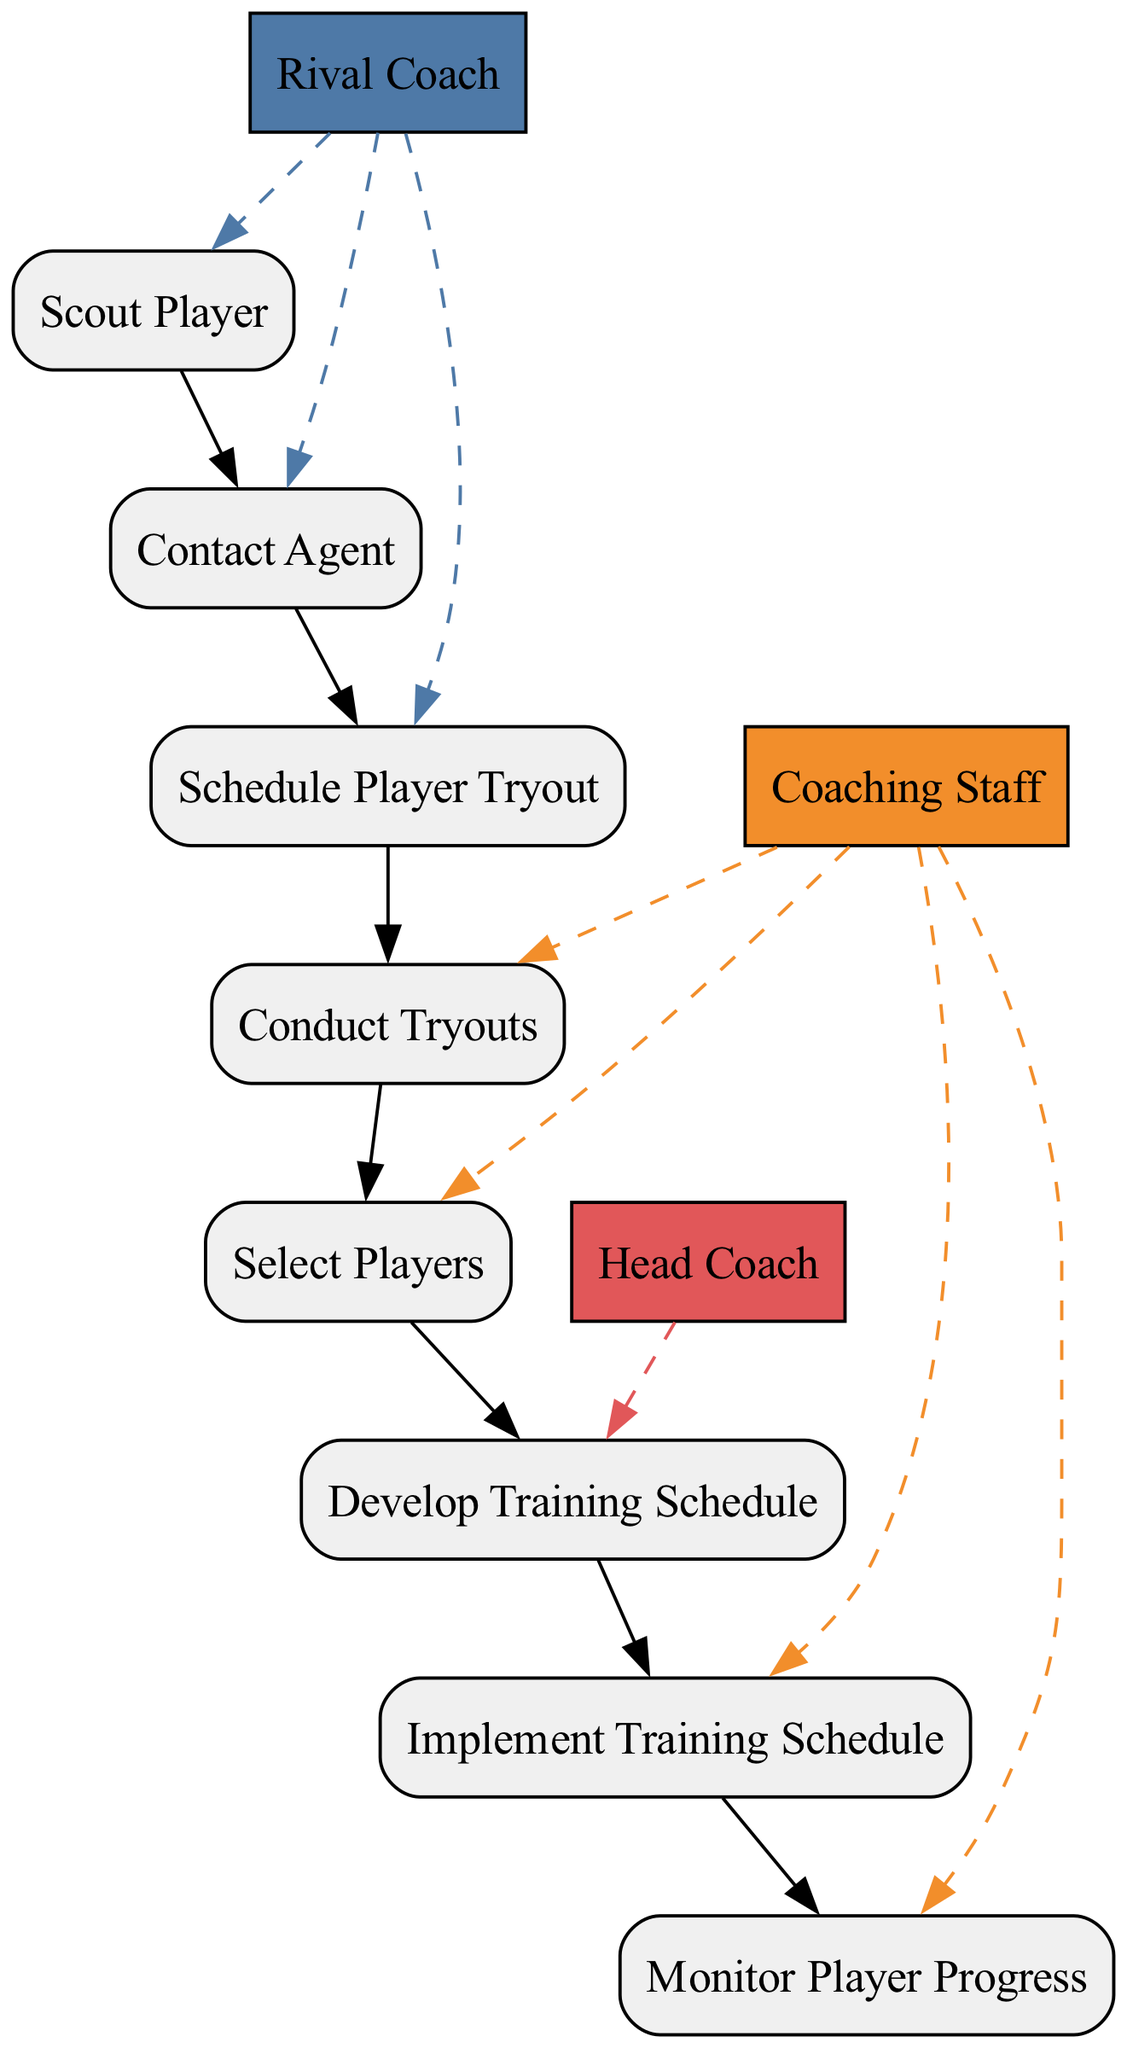What is the first action in the sequence? The first action is represented by the initial node, which is "Scout Player," indicating that evaluating potential players occurs first.
Answer: Scout Player How many different actors are involved in the process? By reviewing the diagram, I can count the unique actors listed, which are "Rival Coach," "Coaching Staff," and "Head Coach," totaling three distinct actors involved.
Answer: Three Which action is performed by the Head Coach? The only action associated with the Head Coach is "Develop Training Schedule," indicating their specific role in the process.
Answer: Develop Training Schedule What is the relationship between 'Select Players' and 'Conduct Tryouts'? The action 'Select Players' occurs after 'Conduct Tryouts,' indicating a sequential relationship where players are assessed before selection can take place.
Answer: Sequential How many edges connect the 'Contact Agent' node to others? The 'Contact Agent' node connects to the 'Schedule Player Tryout' with one edge, showing a direct relationship between these two actions.
Answer: One Which action follows after 'Implement Training Schedule'? The next action following 'Implement Training Schedule' is 'Monitor Player Progress,' suggesting continuous evaluation post-implementation.
Answer: Monitor Player Progress What action is performed before 'Select Players'? The action that is performed directly before 'Select Players' is 'Conduct Tryouts,' indicating the order of operations leading to player selection.
Answer: Conduct Tryouts What is the purpose of 'Monitor Player Progress'? This action serves the purpose of regularly evaluating the development of players and making necessary adjustments to their training based on this evaluation.
Answer: Evaluate development Which actor is responsible for 'Conduct Tryouts'? The action 'Conduct Tryouts' is performed by the "Coaching Staff," assigning this duty to that specific group.
Answer: Coaching Staff 